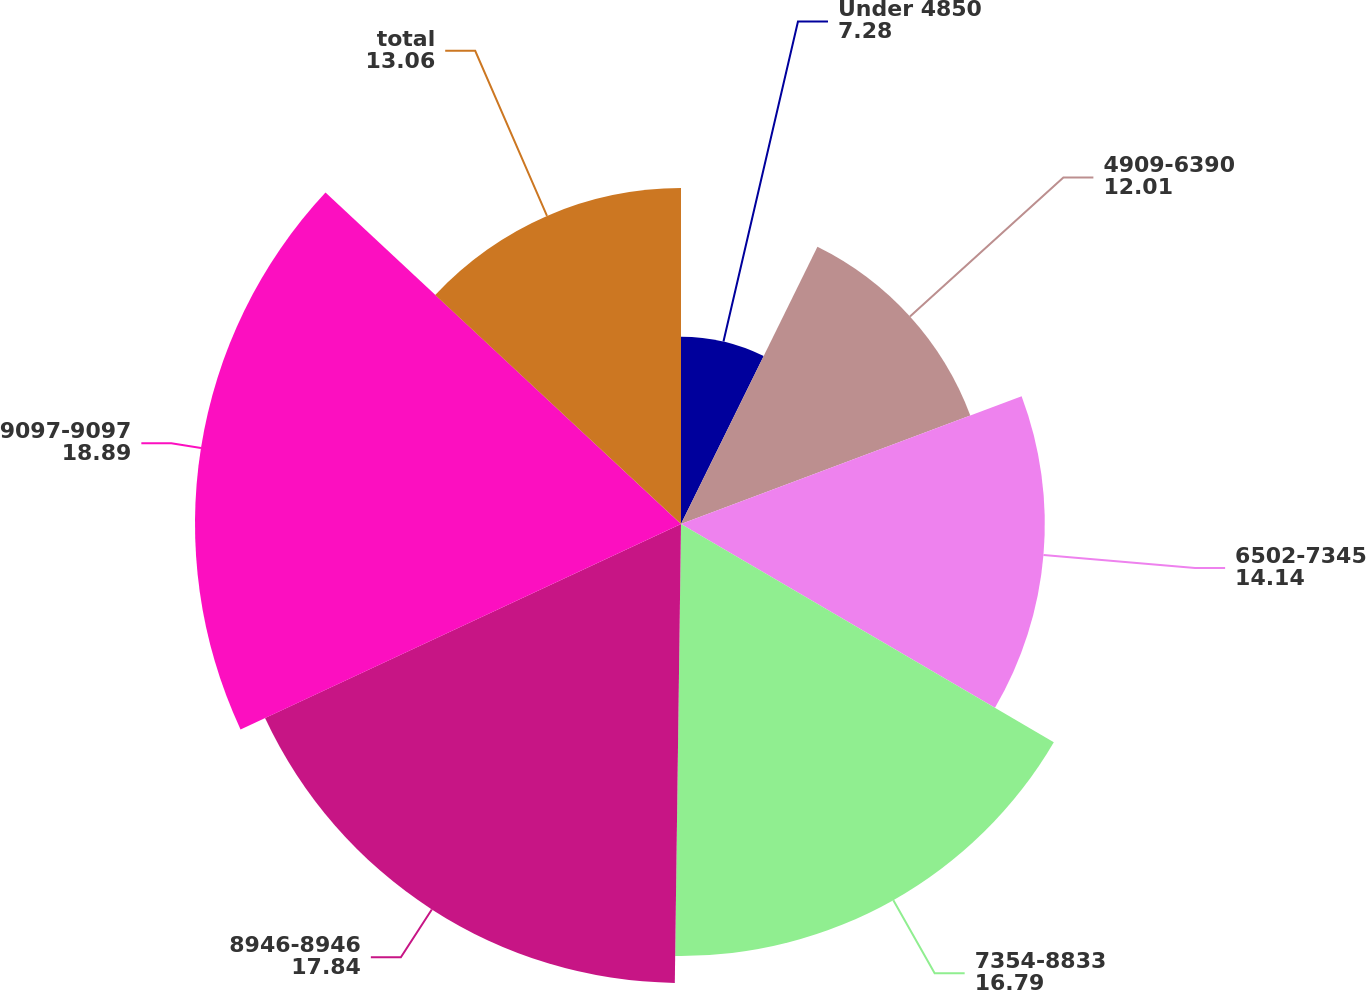<chart> <loc_0><loc_0><loc_500><loc_500><pie_chart><fcel>Under 4850<fcel>4909-6390<fcel>6502-7345<fcel>7354-8833<fcel>8946-8946<fcel>9097-9097<fcel>total<nl><fcel>7.28%<fcel>12.01%<fcel>14.14%<fcel>16.79%<fcel>17.84%<fcel>18.89%<fcel>13.06%<nl></chart> 